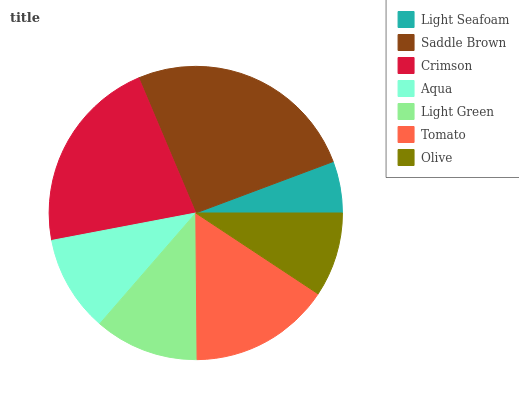Is Light Seafoam the minimum?
Answer yes or no. Yes. Is Saddle Brown the maximum?
Answer yes or no. Yes. Is Crimson the minimum?
Answer yes or no. No. Is Crimson the maximum?
Answer yes or no. No. Is Saddle Brown greater than Crimson?
Answer yes or no. Yes. Is Crimson less than Saddle Brown?
Answer yes or no. Yes. Is Crimson greater than Saddle Brown?
Answer yes or no. No. Is Saddle Brown less than Crimson?
Answer yes or no. No. Is Light Green the high median?
Answer yes or no. Yes. Is Light Green the low median?
Answer yes or no. Yes. Is Aqua the high median?
Answer yes or no. No. Is Tomato the low median?
Answer yes or no. No. 